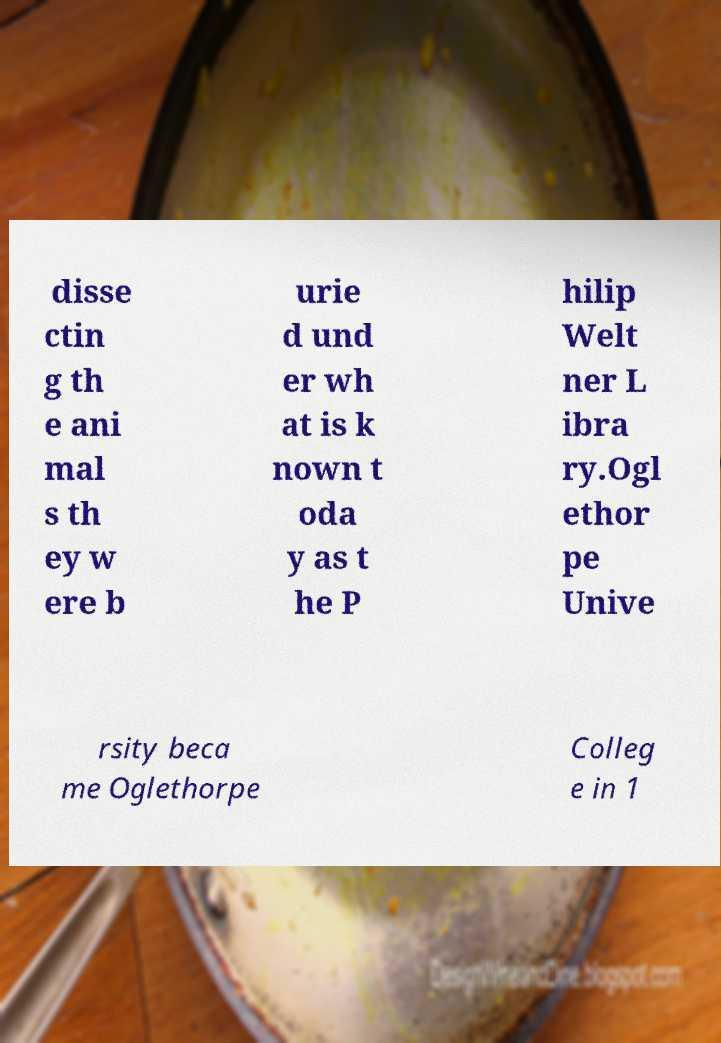Please identify and transcribe the text found in this image. disse ctin g th e ani mal s th ey w ere b urie d und er wh at is k nown t oda y as t he P hilip Welt ner L ibra ry.Ogl ethor pe Unive rsity beca me Oglethorpe Colleg e in 1 